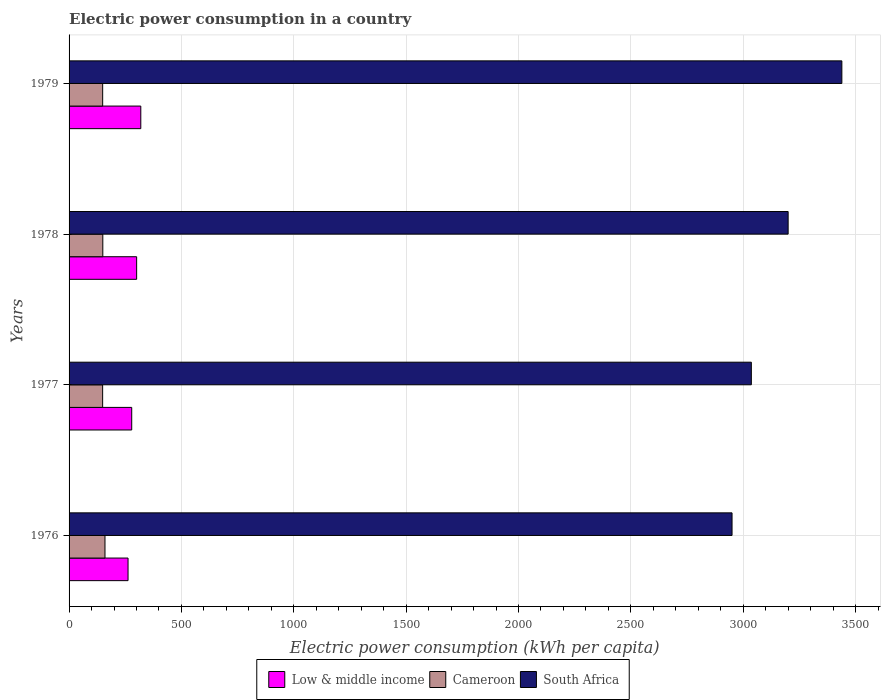How many different coloured bars are there?
Keep it short and to the point. 3. How many groups of bars are there?
Your answer should be very brief. 4. Are the number of bars on each tick of the Y-axis equal?
Provide a succinct answer. Yes. How many bars are there on the 4th tick from the top?
Your response must be concise. 3. What is the label of the 1st group of bars from the top?
Provide a short and direct response. 1979. In how many cases, is the number of bars for a given year not equal to the number of legend labels?
Offer a very short reply. 0. What is the electric power consumption in in Cameroon in 1976?
Give a very brief answer. 159.81. Across all years, what is the maximum electric power consumption in in South Africa?
Keep it short and to the point. 3439.02. Across all years, what is the minimum electric power consumption in in Cameroon?
Make the answer very short. 149.37. In which year was the electric power consumption in in Low & middle income maximum?
Provide a succinct answer. 1979. In which year was the electric power consumption in in Cameroon minimum?
Provide a short and direct response. 1977. What is the total electric power consumption in in South Africa in the graph?
Offer a very short reply. 1.26e+04. What is the difference between the electric power consumption in in Cameroon in 1978 and that in 1979?
Offer a terse response. 0.6. What is the difference between the electric power consumption in in Low & middle income in 1977 and the electric power consumption in in South Africa in 1976?
Make the answer very short. -2671.56. What is the average electric power consumption in in Cameroon per year?
Give a very brief answer. 152.21. In the year 1979, what is the difference between the electric power consumption in in South Africa and electric power consumption in in Cameroon?
Make the answer very short. 3289.49. What is the ratio of the electric power consumption in in Cameroon in 1976 to that in 1979?
Your response must be concise. 1.07. Is the electric power consumption in in Low & middle income in 1976 less than that in 1977?
Provide a short and direct response. Yes. Is the difference between the electric power consumption in in South Africa in 1976 and 1978 greater than the difference between the electric power consumption in in Cameroon in 1976 and 1978?
Make the answer very short. No. What is the difference between the highest and the second highest electric power consumption in in Cameroon?
Provide a short and direct response. 9.67. What is the difference between the highest and the lowest electric power consumption in in Cameroon?
Give a very brief answer. 10.44. In how many years, is the electric power consumption in in South Africa greater than the average electric power consumption in in South Africa taken over all years?
Your response must be concise. 2. Is the sum of the electric power consumption in in South Africa in 1976 and 1979 greater than the maximum electric power consumption in in Low & middle income across all years?
Ensure brevity in your answer.  Yes. What does the 1st bar from the top in 1979 represents?
Your answer should be very brief. South Africa. What does the 3rd bar from the bottom in 1976 represents?
Make the answer very short. South Africa. How many bars are there?
Offer a terse response. 12. Are all the bars in the graph horizontal?
Offer a very short reply. Yes. Are the values on the major ticks of X-axis written in scientific E-notation?
Your answer should be very brief. No. Where does the legend appear in the graph?
Your response must be concise. Bottom center. How many legend labels are there?
Ensure brevity in your answer.  3. What is the title of the graph?
Your answer should be compact. Electric power consumption in a country. Does "Middle East & North Africa (all income levels)" appear as one of the legend labels in the graph?
Ensure brevity in your answer.  No. What is the label or title of the X-axis?
Give a very brief answer. Electric power consumption (kWh per capita). What is the label or title of the Y-axis?
Ensure brevity in your answer.  Years. What is the Electric power consumption (kWh per capita) in Low & middle income in 1976?
Provide a succinct answer. 262.42. What is the Electric power consumption (kWh per capita) in Cameroon in 1976?
Your response must be concise. 159.81. What is the Electric power consumption (kWh per capita) of South Africa in 1976?
Make the answer very short. 2950.36. What is the Electric power consumption (kWh per capita) in Low & middle income in 1977?
Offer a terse response. 278.8. What is the Electric power consumption (kWh per capita) in Cameroon in 1977?
Provide a short and direct response. 149.37. What is the Electric power consumption (kWh per capita) in South Africa in 1977?
Give a very brief answer. 3036.24. What is the Electric power consumption (kWh per capita) in Low & middle income in 1978?
Keep it short and to the point. 300.69. What is the Electric power consumption (kWh per capita) of Cameroon in 1978?
Ensure brevity in your answer.  150.14. What is the Electric power consumption (kWh per capita) in South Africa in 1978?
Give a very brief answer. 3200. What is the Electric power consumption (kWh per capita) of Low & middle income in 1979?
Make the answer very short. 319.18. What is the Electric power consumption (kWh per capita) of Cameroon in 1979?
Keep it short and to the point. 149.53. What is the Electric power consumption (kWh per capita) in South Africa in 1979?
Give a very brief answer. 3439.02. Across all years, what is the maximum Electric power consumption (kWh per capita) of Low & middle income?
Keep it short and to the point. 319.18. Across all years, what is the maximum Electric power consumption (kWh per capita) in Cameroon?
Your answer should be compact. 159.81. Across all years, what is the maximum Electric power consumption (kWh per capita) of South Africa?
Offer a very short reply. 3439.02. Across all years, what is the minimum Electric power consumption (kWh per capita) of Low & middle income?
Give a very brief answer. 262.42. Across all years, what is the minimum Electric power consumption (kWh per capita) in Cameroon?
Ensure brevity in your answer.  149.37. Across all years, what is the minimum Electric power consumption (kWh per capita) of South Africa?
Your response must be concise. 2950.36. What is the total Electric power consumption (kWh per capita) of Low & middle income in the graph?
Your answer should be compact. 1161.09. What is the total Electric power consumption (kWh per capita) of Cameroon in the graph?
Provide a succinct answer. 608.85. What is the total Electric power consumption (kWh per capita) in South Africa in the graph?
Provide a short and direct response. 1.26e+04. What is the difference between the Electric power consumption (kWh per capita) in Low & middle income in 1976 and that in 1977?
Provide a succinct answer. -16.38. What is the difference between the Electric power consumption (kWh per capita) of Cameroon in 1976 and that in 1977?
Offer a very short reply. 10.44. What is the difference between the Electric power consumption (kWh per capita) in South Africa in 1976 and that in 1977?
Ensure brevity in your answer.  -85.88. What is the difference between the Electric power consumption (kWh per capita) of Low & middle income in 1976 and that in 1978?
Provide a succinct answer. -38.26. What is the difference between the Electric power consumption (kWh per capita) in Cameroon in 1976 and that in 1978?
Give a very brief answer. 9.67. What is the difference between the Electric power consumption (kWh per capita) of South Africa in 1976 and that in 1978?
Provide a short and direct response. -249.64. What is the difference between the Electric power consumption (kWh per capita) in Low & middle income in 1976 and that in 1979?
Provide a succinct answer. -56.76. What is the difference between the Electric power consumption (kWh per capita) of Cameroon in 1976 and that in 1979?
Your response must be concise. 10.28. What is the difference between the Electric power consumption (kWh per capita) in South Africa in 1976 and that in 1979?
Keep it short and to the point. -488.66. What is the difference between the Electric power consumption (kWh per capita) of Low & middle income in 1977 and that in 1978?
Ensure brevity in your answer.  -21.89. What is the difference between the Electric power consumption (kWh per capita) in Cameroon in 1977 and that in 1978?
Your answer should be very brief. -0.77. What is the difference between the Electric power consumption (kWh per capita) of South Africa in 1977 and that in 1978?
Your response must be concise. -163.76. What is the difference between the Electric power consumption (kWh per capita) of Low & middle income in 1977 and that in 1979?
Offer a very short reply. -40.38. What is the difference between the Electric power consumption (kWh per capita) of Cameroon in 1977 and that in 1979?
Offer a terse response. -0.17. What is the difference between the Electric power consumption (kWh per capita) of South Africa in 1977 and that in 1979?
Offer a terse response. -402.78. What is the difference between the Electric power consumption (kWh per capita) in Low & middle income in 1978 and that in 1979?
Provide a succinct answer. -18.5. What is the difference between the Electric power consumption (kWh per capita) of Cameroon in 1978 and that in 1979?
Make the answer very short. 0.6. What is the difference between the Electric power consumption (kWh per capita) in South Africa in 1978 and that in 1979?
Offer a terse response. -239.02. What is the difference between the Electric power consumption (kWh per capita) in Low & middle income in 1976 and the Electric power consumption (kWh per capita) in Cameroon in 1977?
Your answer should be compact. 113.05. What is the difference between the Electric power consumption (kWh per capita) of Low & middle income in 1976 and the Electric power consumption (kWh per capita) of South Africa in 1977?
Provide a succinct answer. -2773.82. What is the difference between the Electric power consumption (kWh per capita) of Cameroon in 1976 and the Electric power consumption (kWh per capita) of South Africa in 1977?
Keep it short and to the point. -2876.43. What is the difference between the Electric power consumption (kWh per capita) of Low & middle income in 1976 and the Electric power consumption (kWh per capita) of Cameroon in 1978?
Your response must be concise. 112.29. What is the difference between the Electric power consumption (kWh per capita) of Low & middle income in 1976 and the Electric power consumption (kWh per capita) of South Africa in 1978?
Offer a very short reply. -2937.58. What is the difference between the Electric power consumption (kWh per capita) of Cameroon in 1976 and the Electric power consumption (kWh per capita) of South Africa in 1978?
Provide a succinct answer. -3040.19. What is the difference between the Electric power consumption (kWh per capita) in Low & middle income in 1976 and the Electric power consumption (kWh per capita) in Cameroon in 1979?
Offer a terse response. 112.89. What is the difference between the Electric power consumption (kWh per capita) in Low & middle income in 1976 and the Electric power consumption (kWh per capita) in South Africa in 1979?
Keep it short and to the point. -3176.6. What is the difference between the Electric power consumption (kWh per capita) of Cameroon in 1976 and the Electric power consumption (kWh per capita) of South Africa in 1979?
Offer a terse response. -3279.21. What is the difference between the Electric power consumption (kWh per capita) of Low & middle income in 1977 and the Electric power consumption (kWh per capita) of Cameroon in 1978?
Provide a succinct answer. 128.66. What is the difference between the Electric power consumption (kWh per capita) in Low & middle income in 1977 and the Electric power consumption (kWh per capita) in South Africa in 1978?
Give a very brief answer. -2921.2. What is the difference between the Electric power consumption (kWh per capita) in Cameroon in 1977 and the Electric power consumption (kWh per capita) in South Africa in 1978?
Provide a succinct answer. -3050.63. What is the difference between the Electric power consumption (kWh per capita) of Low & middle income in 1977 and the Electric power consumption (kWh per capita) of Cameroon in 1979?
Provide a short and direct response. 129.27. What is the difference between the Electric power consumption (kWh per capita) in Low & middle income in 1977 and the Electric power consumption (kWh per capita) in South Africa in 1979?
Give a very brief answer. -3160.22. What is the difference between the Electric power consumption (kWh per capita) of Cameroon in 1977 and the Electric power consumption (kWh per capita) of South Africa in 1979?
Keep it short and to the point. -3289.65. What is the difference between the Electric power consumption (kWh per capita) of Low & middle income in 1978 and the Electric power consumption (kWh per capita) of Cameroon in 1979?
Offer a terse response. 151.15. What is the difference between the Electric power consumption (kWh per capita) in Low & middle income in 1978 and the Electric power consumption (kWh per capita) in South Africa in 1979?
Make the answer very short. -3138.34. What is the difference between the Electric power consumption (kWh per capita) of Cameroon in 1978 and the Electric power consumption (kWh per capita) of South Africa in 1979?
Provide a short and direct response. -3288.89. What is the average Electric power consumption (kWh per capita) of Low & middle income per year?
Offer a very short reply. 290.27. What is the average Electric power consumption (kWh per capita) in Cameroon per year?
Your response must be concise. 152.21. What is the average Electric power consumption (kWh per capita) of South Africa per year?
Make the answer very short. 3156.41. In the year 1976, what is the difference between the Electric power consumption (kWh per capita) of Low & middle income and Electric power consumption (kWh per capita) of Cameroon?
Provide a short and direct response. 102.61. In the year 1976, what is the difference between the Electric power consumption (kWh per capita) in Low & middle income and Electric power consumption (kWh per capita) in South Africa?
Your answer should be very brief. -2687.94. In the year 1976, what is the difference between the Electric power consumption (kWh per capita) in Cameroon and Electric power consumption (kWh per capita) in South Africa?
Offer a very short reply. -2790.55. In the year 1977, what is the difference between the Electric power consumption (kWh per capita) in Low & middle income and Electric power consumption (kWh per capita) in Cameroon?
Your answer should be compact. 129.43. In the year 1977, what is the difference between the Electric power consumption (kWh per capita) in Low & middle income and Electric power consumption (kWh per capita) in South Africa?
Provide a short and direct response. -2757.44. In the year 1977, what is the difference between the Electric power consumption (kWh per capita) in Cameroon and Electric power consumption (kWh per capita) in South Africa?
Offer a terse response. -2886.88. In the year 1978, what is the difference between the Electric power consumption (kWh per capita) of Low & middle income and Electric power consumption (kWh per capita) of Cameroon?
Offer a terse response. 150.55. In the year 1978, what is the difference between the Electric power consumption (kWh per capita) in Low & middle income and Electric power consumption (kWh per capita) in South Africa?
Your answer should be compact. -2899.31. In the year 1978, what is the difference between the Electric power consumption (kWh per capita) of Cameroon and Electric power consumption (kWh per capita) of South Africa?
Your response must be concise. -3049.86. In the year 1979, what is the difference between the Electric power consumption (kWh per capita) in Low & middle income and Electric power consumption (kWh per capita) in Cameroon?
Provide a succinct answer. 169.65. In the year 1979, what is the difference between the Electric power consumption (kWh per capita) of Low & middle income and Electric power consumption (kWh per capita) of South Africa?
Offer a very short reply. -3119.84. In the year 1979, what is the difference between the Electric power consumption (kWh per capita) in Cameroon and Electric power consumption (kWh per capita) in South Africa?
Provide a short and direct response. -3289.49. What is the ratio of the Electric power consumption (kWh per capita) of Low & middle income in 1976 to that in 1977?
Offer a very short reply. 0.94. What is the ratio of the Electric power consumption (kWh per capita) of Cameroon in 1976 to that in 1977?
Your answer should be compact. 1.07. What is the ratio of the Electric power consumption (kWh per capita) of South Africa in 1976 to that in 1977?
Ensure brevity in your answer.  0.97. What is the ratio of the Electric power consumption (kWh per capita) of Low & middle income in 1976 to that in 1978?
Offer a terse response. 0.87. What is the ratio of the Electric power consumption (kWh per capita) of Cameroon in 1976 to that in 1978?
Keep it short and to the point. 1.06. What is the ratio of the Electric power consumption (kWh per capita) of South Africa in 1976 to that in 1978?
Ensure brevity in your answer.  0.92. What is the ratio of the Electric power consumption (kWh per capita) of Low & middle income in 1976 to that in 1979?
Provide a succinct answer. 0.82. What is the ratio of the Electric power consumption (kWh per capita) of Cameroon in 1976 to that in 1979?
Your answer should be very brief. 1.07. What is the ratio of the Electric power consumption (kWh per capita) of South Africa in 1976 to that in 1979?
Make the answer very short. 0.86. What is the ratio of the Electric power consumption (kWh per capita) in Low & middle income in 1977 to that in 1978?
Provide a succinct answer. 0.93. What is the ratio of the Electric power consumption (kWh per capita) of Cameroon in 1977 to that in 1978?
Your response must be concise. 0.99. What is the ratio of the Electric power consumption (kWh per capita) in South Africa in 1977 to that in 1978?
Your answer should be compact. 0.95. What is the ratio of the Electric power consumption (kWh per capita) of Low & middle income in 1977 to that in 1979?
Your answer should be compact. 0.87. What is the ratio of the Electric power consumption (kWh per capita) of Cameroon in 1977 to that in 1979?
Your answer should be very brief. 1. What is the ratio of the Electric power consumption (kWh per capita) of South Africa in 1977 to that in 1979?
Ensure brevity in your answer.  0.88. What is the ratio of the Electric power consumption (kWh per capita) of Low & middle income in 1978 to that in 1979?
Offer a terse response. 0.94. What is the ratio of the Electric power consumption (kWh per capita) in Cameroon in 1978 to that in 1979?
Make the answer very short. 1. What is the ratio of the Electric power consumption (kWh per capita) of South Africa in 1978 to that in 1979?
Offer a terse response. 0.93. What is the difference between the highest and the second highest Electric power consumption (kWh per capita) in Low & middle income?
Provide a short and direct response. 18.5. What is the difference between the highest and the second highest Electric power consumption (kWh per capita) in Cameroon?
Provide a succinct answer. 9.67. What is the difference between the highest and the second highest Electric power consumption (kWh per capita) in South Africa?
Keep it short and to the point. 239.02. What is the difference between the highest and the lowest Electric power consumption (kWh per capita) of Low & middle income?
Keep it short and to the point. 56.76. What is the difference between the highest and the lowest Electric power consumption (kWh per capita) of Cameroon?
Provide a succinct answer. 10.44. What is the difference between the highest and the lowest Electric power consumption (kWh per capita) in South Africa?
Ensure brevity in your answer.  488.66. 